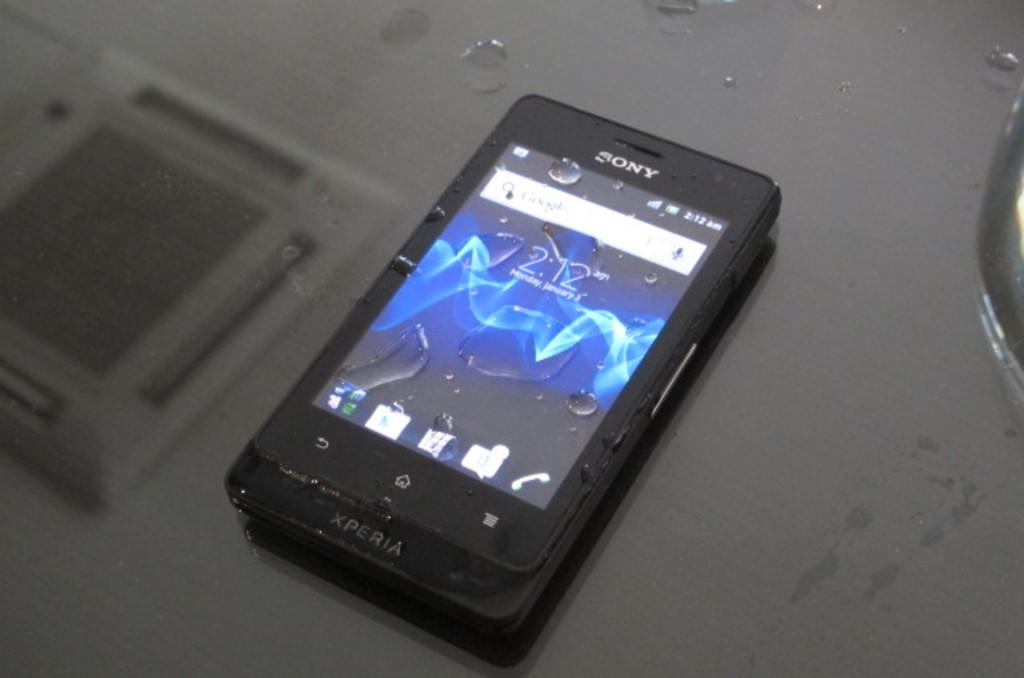Provide a one-sentence caption for the provided image. A Sony phone displays the time as 2:12. 